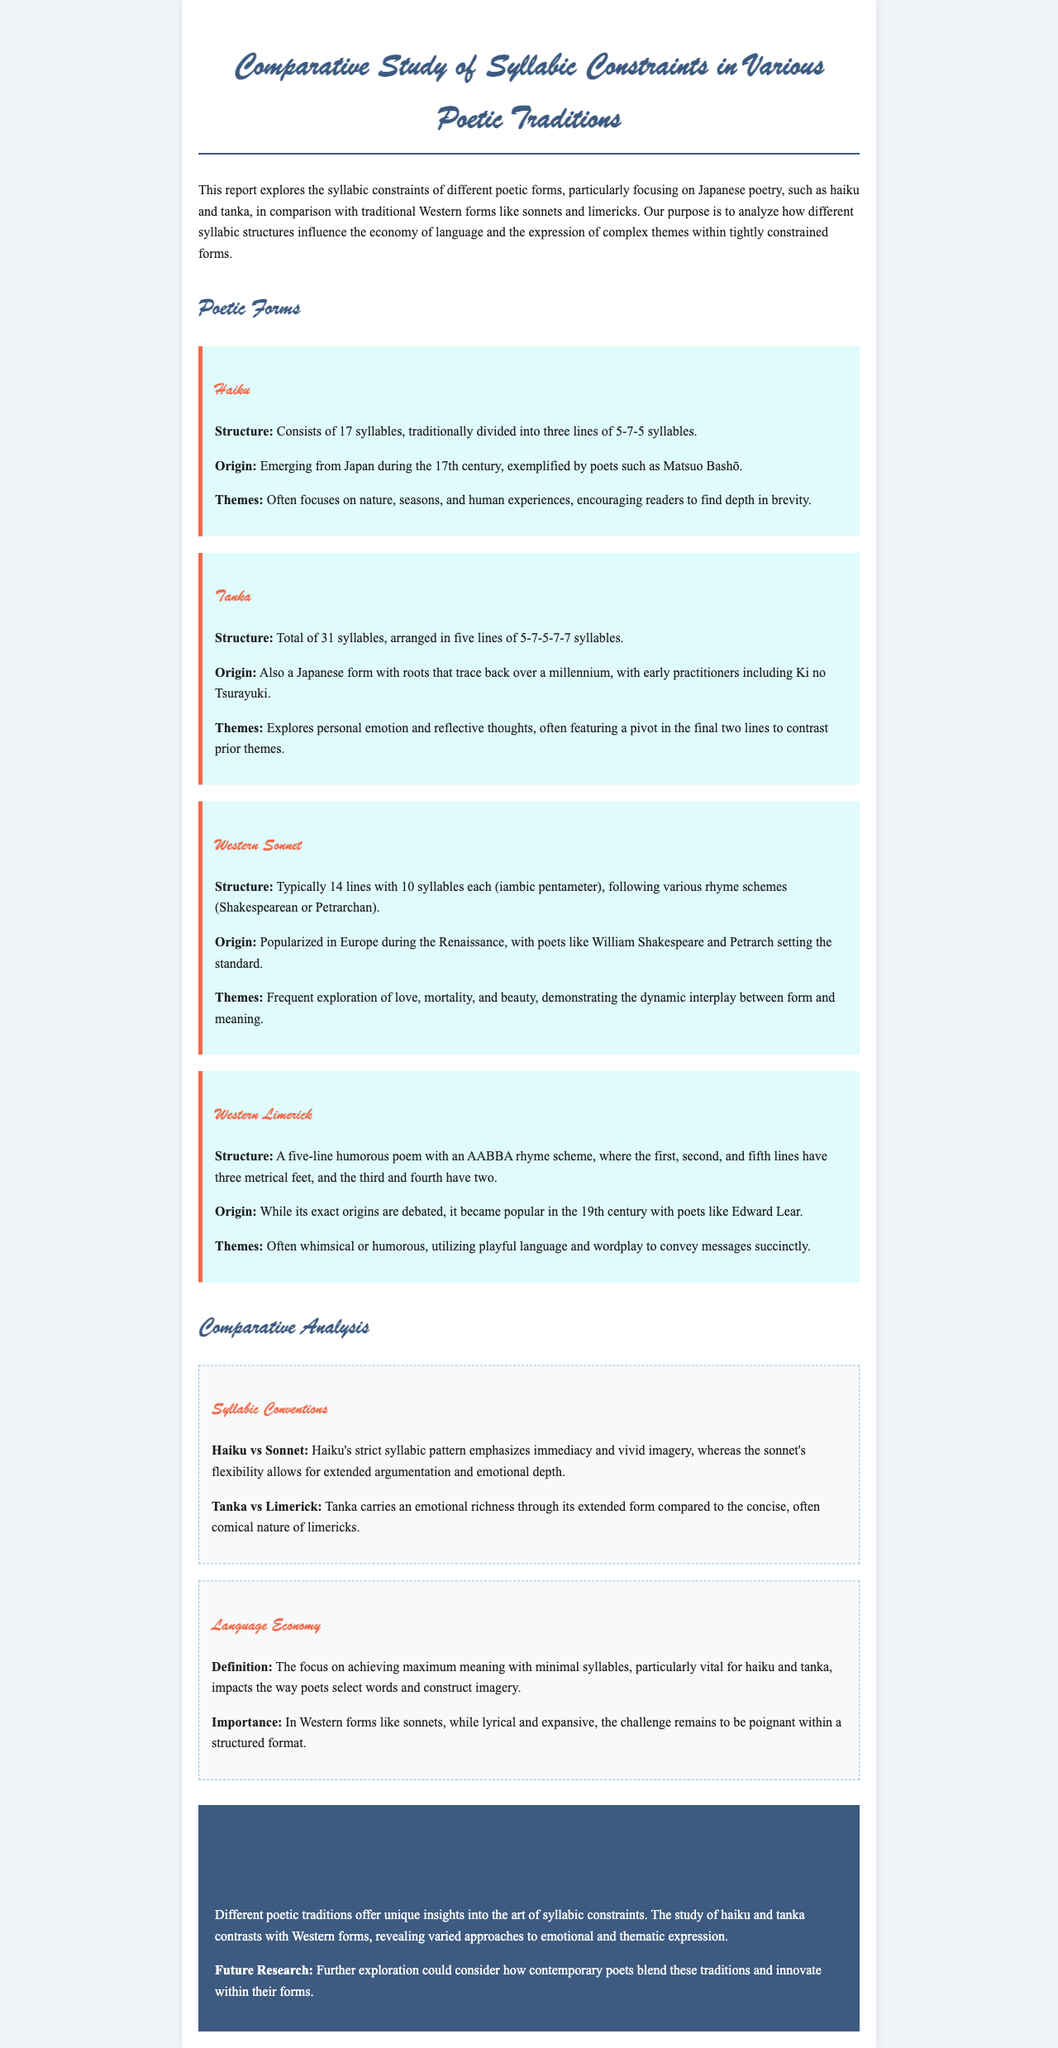What is the structure of a haiku? The structure of a haiku consists of 17 syllables, traditionally divided into three lines of 5-7-5 syllables.
Answer: 17 syllables, 5-7-5 Who is a notable poet associated with haiku? A notable poet associated with haiku is Matsuo Bashō.
Answer: Matsuo Bashō How many lines are in a tanka? A tanka consists of five lines.
Answer: Five lines What is the rhyme scheme of a limerick? The rhyme scheme of a limerick is AABBA.
Answer: AABBA What does the term "language economy" refer to in poetry? Language economy refers to achieving maximum meaning with minimal syllables.
Answer: Maximum meaning with minimal syllables How does the haiku's syllabic pattern affect its imagery compared to a sonnet? The haiku's strict syllabic pattern emphasizes immediacy and vivid imagery, while the sonnet's flexibility allows for extended argumentation and emotional depth.
Answer: Emphasizes immediacy and vivid imagery What type of emotional expression does tanka primarily explore? Tanka primarily explores personal emotion and reflective thoughts.
Answer: Personal emotion and reflective thoughts What could future research consider according to the conclusion? Future research could consider how contemporary poets blend these traditions and innovate within their forms.
Answer: Blending traditions and innovation 